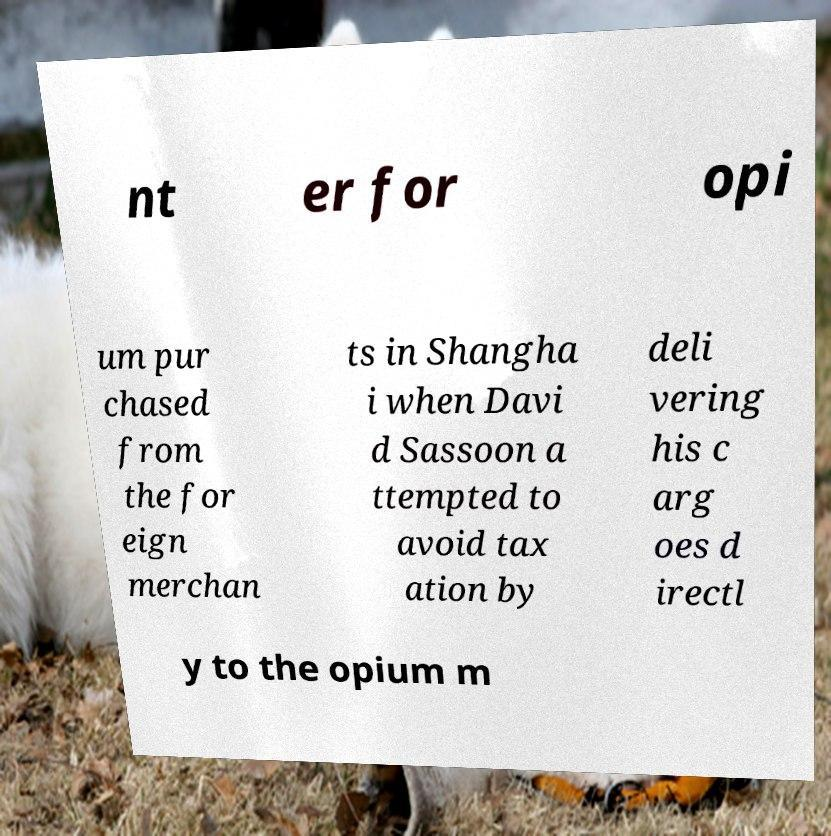What messages or text are displayed in this image? I need them in a readable, typed format. nt er for opi um pur chased from the for eign merchan ts in Shangha i when Davi d Sassoon a ttempted to avoid tax ation by deli vering his c arg oes d irectl y to the opium m 